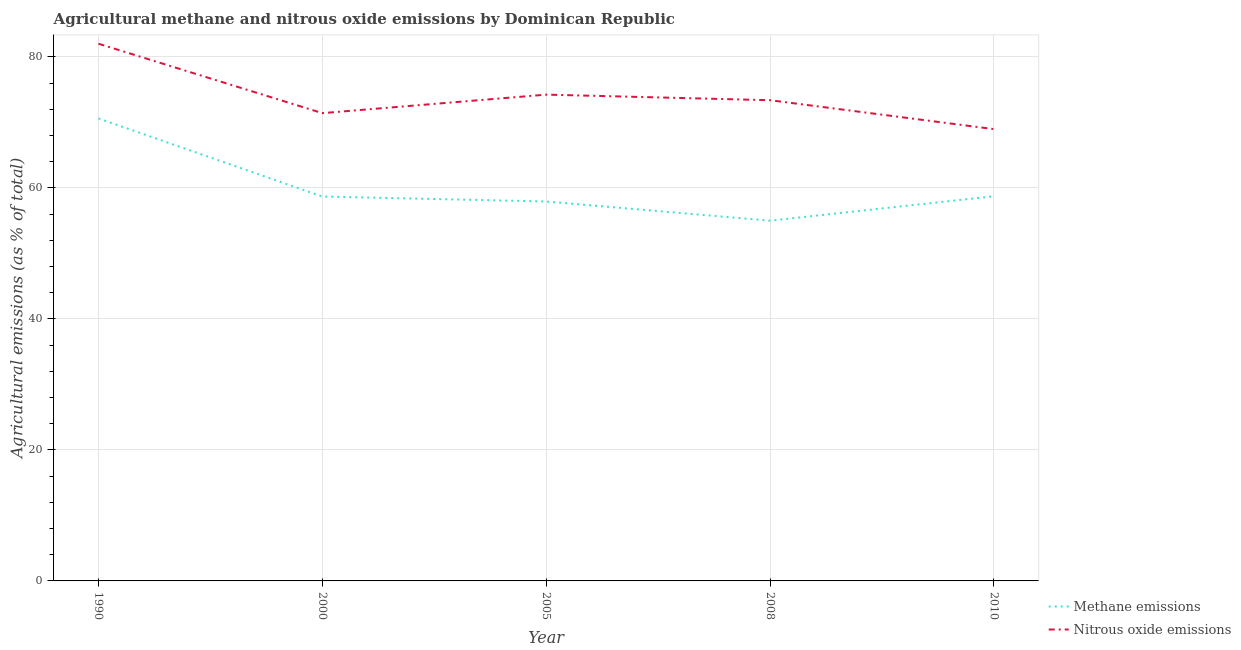Does the line corresponding to amount of methane emissions intersect with the line corresponding to amount of nitrous oxide emissions?
Your answer should be compact. No. What is the amount of methane emissions in 2005?
Give a very brief answer. 57.94. Across all years, what is the maximum amount of nitrous oxide emissions?
Ensure brevity in your answer.  82.03. Across all years, what is the minimum amount of methane emissions?
Provide a short and direct response. 55. What is the total amount of methane emissions in the graph?
Your answer should be compact. 300.99. What is the difference between the amount of nitrous oxide emissions in 2008 and that in 2010?
Offer a very short reply. 4.41. What is the difference between the amount of methane emissions in 2008 and the amount of nitrous oxide emissions in 2000?
Ensure brevity in your answer.  -16.42. What is the average amount of nitrous oxide emissions per year?
Give a very brief answer. 74.02. In the year 2010, what is the difference between the amount of methane emissions and amount of nitrous oxide emissions?
Keep it short and to the point. -10.25. What is the ratio of the amount of methane emissions in 2005 to that in 2008?
Make the answer very short. 1.05. Is the amount of nitrous oxide emissions in 2000 less than that in 2010?
Keep it short and to the point. No. What is the difference between the highest and the second highest amount of nitrous oxide emissions?
Offer a terse response. 7.77. What is the difference between the highest and the lowest amount of nitrous oxide emissions?
Offer a very short reply. 13.04. Is the sum of the amount of methane emissions in 1990 and 2010 greater than the maximum amount of nitrous oxide emissions across all years?
Your answer should be very brief. Yes. Does the amount of methane emissions monotonically increase over the years?
Make the answer very short. No. Is the amount of nitrous oxide emissions strictly greater than the amount of methane emissions over the years?
Provide a short and direct response. Yes. What is the difference between two consecutive major ticks on the Y-axis?
Keep it short and to the point. 20. Does the graph contain any zero values?
Your answer should be compact. No. How many legend labels are there?
Give a very brief answer. 2. How are the legend labels stacked?
Your answer should be very brief. Vertical. What is the title of the graph?
Ensure brevity in your answer.  Agricultural methane and nitrous oxide emissions by Dominican Republic. What is the label or title of the X-axis?
Ensure brevity in your answer.  Year. What is the label or title of the Y-axis?
Ensure brevity in your answer.  Agricultural emissions (as % of total). What is the Agricultural emissions (as % of total) in Methane emissions in 1990?
Your answer should be compact. 70.62. What is the Agricultural emissions (as % of total) in Nitrous oxide emissions in 1990?
Your answer should be compact. 82.03. What is the Agricultural emissions (as % of total) in Methane emissions in 2000?
Your answer should be very brief. 58.69. What is the Agricultural emissions (as % of total) in Nitrous oxide emissions in 2000?
Offer a terse response. 71.43. What is the Agricultural emissions (as % of total) in Methane emissions in 2005?
Your response must be concise. 57.94. What is the Agricultural emissions (as % of total) of Nitrous oxide emissions in 2005?
Provide a succinct answer. 74.25. What is the Agricultural emissions (as % of total) in Methane emissions in 2008?
Your response must be concise. 55. What is the Agricultural emissions (as % of total) in Nitrous oxide emissions in 2008?
Ensure brevity in your answer.  73.4. What is the Agricultural emissions (as % of total) in Methane emissions in 2010?
Offer a terse response. 58.74. What is the Agricultural emissions (as % of total) in Nitrous oxide emissions in 2010?
Keep it short and to the point. 68.99. Across all years, what is the maximum Agricultural emissions (as % of total) in Methane emissions?
Your answer should be very brief. 70.62. Across all years, what is the maximum Agricultural emissions (as % of total) of Nitrous oxide emissions?
Make the answer very short. 82.03. Across all years, what is the minimum Agricultural emissions (as % of total) of Methane emissions?
Your answer should be very brief. 55. Across all years, what is the minimum Agricultural emissions (as % of total) of Nitrous oxide emissions?
Offer a very short reply. 68.99. What is the total Agricultural emissions (as % of total) of Methane emissions in the graph?
Make the answer very short. 300.99. What is the total Agricultural emissions (as % of total) of Nitrous oxide emissions in the graph?
Keep it short and to the point. 370.09. What is the difference between the Agricultural emissions (as % of total) of Methane emissions in 1990 and that in 2000?
Make the answer very short. 11.92. What is the difference between the Agricultural emissions (as % of total) of Nitrous oxide emissions in 1990 and that in 2000?
Provide a short and direct response. 10.6. What is the difference between the Agricultural emissions (as % of total) of Methane emissions in 1990 and that in 2005?
Make the answer very short. 12.68. What is the difference between the Agricultural emissions (as % of total) of Nitrous oxide emissions in 1990 and that in 2005?
Give a very brief answer. 7.77. What is the difference between the Agricultural emissions (as % of total) of Methane emissions in 1990 and that in 2008?
Give a very brief answer. 15.61. What is the difference between the Agricultural emissions (as % of total) of Nitrous oxide emissions in 1990 and that in 2008?
Offer a very short reply. 8.63. What is the difference between the Agricultural emissions (as % of total) of Methane emissions in 1990 and that in 2010?
Your answer should be very brief. 11.88. What is the difference between the Agricultural emissions (as % of total) of Nitrous oxide emissions in 1990 and that in 2010?
Your answer should be very brief. 13.04. What is the difference between the Agricultural emissions (as % of total) of Methane emissions in 2000 and that in 2005?
Provide a short and direct response. 0.76. What is the difference between the Agricultural emissions (as % of total) of Nitrous oxide emissions in 2000 and that in 2005?
Provide a succinct answer. -2.83. What is the difference between the Agricultural emissions (as % of total) in Methane emissions in 2000 and that in 2008?
Ensure brevity in your answer.  3.69. What is the difference between the Agricultural emissions (as % of total) of Nitrous oxide emissions in 2000 and that in 2008?
Make the answer very short. -1.97. What is the difference between the Agricultural emissions (as % of total) of Methane emissions in 2000 and that in 2010?
Your answer should be very brief. -0.05. What is the difference between the Agricultural emissions (as % of total) in Nitrous oxide emissions in 2000 and that in 2010?
Ensure brevity in your answer.  2.44. What is the difference between the Agricultural emissions (as % of total) in Methane emissions in 2005 and that in 2008?
Offer a terse response. 2.93. What is the difference between the Agricultural emissions (as % of total) in Nitrous oxide emissions in 2005 and that in 2008?
Make the answer very short. 0.85. What is the difference between the Agricultural emissions (as % of total) in Methane emissions in 2005 and that in 2010?
Provide a succinct answer. -0.81. What is the difference between the Agricultural emissions (as % of total) of Nitrous oxide emissions in 2005 and that in 2010?
Your answer should be very brief. 5.27. What is the difference between the Agricultural emissions (as % of total) in Methane emissions in 2008 and that in 2010?
Provide a succinct answer. -3.74. What is the difference between the Agricultural emissions (as % of total) in Nitrous oxide emissions in 2008 and that in 2010?
Give a very brief answer. 4.41. What is the difference between the Agricultural emissions (as % of total) of Methane emissions in 1990 and the Agricultural emissions (as % of total) of Nitrous oxide emissions in 2000?
Your response must be concise. -0.81. What is the difference between the Agricultural emissions (as % of total) in Methane emissions in 1990 and the Agricultural emissions (as % of total) in Nitrous oxide emissions in 2005?
Offer a very short reply. -3.63. What is the difference between the Agricultural emissions (as % of total) in Methane emissions in 1990 and the Agricultural emissions (as % of total) in Nitrous oxide emissions in 2008?
Provide a short and direct response. -2.78. What is the difference between the Agricultural emissions (as % of total) in Methane emissions in 1990 and the Agricultural emissions (as % of total) in Nitrous oxide emissions in 2010?
Provide a short and direct response. 1.63. What is the difference between the Agricultural emissions (as % of total) of Methane emissions in 2000 and the Agricultural emissions (as % of total) of Nitrous oxide emissions in 2005?
Your answer should be compact. -15.56. What is the difference between the Agricultural emissions (as % of total) of Methane emissions in 2000 and the Agricultural emissions (as % of total) of Nitrous oxide emissions in 2008?
Offer a terse response. -14.71. What is the difference between the Agricultural emissions (as % of total) of Methane emissions in 2000 and the Agricultural emissions (as % of total) of Nitrous oxide emissions in 2010?
Ensure brevity in your answer.  -10.29. What is the difference between the Agricultural emissions (as % of total) of Methane emissions in 2005 and the Agricultural emissions (as % of total) of Nitrous oxide emissions in 2008?
Make the answer very short. -15.46. What is the difference between the Agricultural emissions (as % of total) in Methane emissions in 2005 and the Agricultural emissions (as % of total) in Nitrous oxide emissions in 2010?
Give a very brief answer. -11.05. What is the difference between the Agricultural emissions (as % of total) in Methane emissions in 2008 and the Agricultural emissions (as % of total) in Nitrous oxide emissions in 2010?
Your answer should be compact. -13.98. What is the average Agricultural emissions (as % of total) of Methane emissions per year?
Your answer should be compact. 60.2. What is the average Agricultural emissions (as % of total) of Nitrous oxide emissions per year?
Offer a terse response. 74.02. In the year 1990, what is the difference between the Agricultural emissions (as % of total) of Methane emissions and Agricultural emissions (as % of total) of Nitrous oxide emissions?
Offer a very short reply. -11.41. In the year 2000, what is the difference between the Agricultural emissions (as % of total) of Methane emissions and Agricultural emissions (as % of total) of Nitrous oxide emissions?
Keep it short and to the point. -12.73. In the year 2005, what is the difference between the Agricultural emissions (as % of total) of Methane emissions and Agricultural emissions (as % of total) of Nitrous oxide emissions?
Make the answer very short. -16.32. In the year 2008, what is the difference between the Agricultural emissions (as % of total) of Methane emissions and Agricultural emissions (as % of total) of Nitrous oxide emissions?
Your response must be concise. -18.4. In the year 2010, what is the difference between the Agricultural emissions (as % of total) in Methane emissions and Agricultural emissions (as % of total) in Nitrous oxide emissions?
Ensure brevity in your answer.  -10.25. What is the ratio of the Agricultural emissions (as % of total) of Methane emissions in 1990 to that in 2000?
Make the answer very short. 1.2. What is the ratio of the Agricultural emissions (as % of total) in Nitrous oxide emissions in 1990 to that in 2000?
Your response must be concise. 1.15. What is the ratio of the Agricultural emissions (as % of total) in Methane emissions in 1990 to that in 2005?
Offer a terse response. 1.22. What is the ratio of the Agricultural emissions (as % of total) of Nitrous oxide emissions in 1990 to that in 2005?
Offer a terse response. 1.1. What is the ratio of the Agricultural emissions (as % of total) in Methane emissions in 1990 to that in 2008?
Make the answer very short. 1.28. What is the ratio of the Agricultural emissions (as % of total) in Nitrous oxide emissions in 1990 to that in 2008?
Keep it short and to the point. 1.12. What is the ratio of the Agricultural emissions (as % of total) in Methane emissions in 1990 to that in 2010?
Keep it short and to the point. 1.2. What is the ratio of the Agricultural emissions (as % of total) of Nitrous oxide emissions in 1990 to that in 2010?
Give a very brief answer. 1.19. What is the ratio of the Agricultural emissions (as % of total) in Methane emissions in 2000 to that in 2005?
Your answer should be very brief. 1.01. What is the ratio of the Agricultural emissions (as % of total) of Nitrous oxide emissions in 2000 to that in 2005?
Your answer should be compact. 0.96. What is the ratio of the Agricultural emissions (as % of total) in Methane emissions in 2000 to that in 2008?
Provide a short and direct response. 1.07. What is the ratio of the Agricultural emissions (as % of total) of Nitrous oxide emissions in 2000 to that in 2008?
Give a very brief answer. 0.97. What is the ratio of the Agricultural emissions (as % of total) in Nitrous oxide emissions in 2000 to that in 2010?
Offer a terse response. 1.04. What is the ratio of the Agricultural emissions (as % of total) of Methane emissions in 2005 to that in 2008?
Offer a terse response. 1.05. What is the ratio of the Agricultural emissions (as % of total) of Nitrous oxide emissions in 2005 to that in 2008?
Offer a very short reply. 1.01. What is the ratio of the Agricultural emissions (as % of total) in Methane emissions in 2005 to that in 2010?
Your answer should be very brief. 0.99. What is the ratio of the Agricultural emissions (as % of total) in Nitrous oxide emissions in 2005 to that in 2010?
Ensure brevity in your answer.  1.08. What is the ratio of the Agricultural emissions (as % of total) of Methane emissions in 2008 to that in 2010?
Your answer should be compact. 0.94. What is the ratio of the Agricultural emissions (as % of total) of Nitrous oxide emissions in 2008 to that in 2010?
Your answer should be very brief. 1.06. What is the difference between the highest and the second highest Agricultural emissions (as % of total) of Methane emissions?
Your response must be concise. 11.88. What is the difference between the highest and the second highest Agricultural emissions (as % of total) of Nitrous oxide emissions?
Offer a terse response. 7.77. What is the difference between the highest and the lowest Agricultural emissions (as % of total) of Methane emissions?
Give a very brief answer. 15.61. What is the difference between the highest and the lowest Agricultural emissions (as % of total) of Nitrous oxide emissions?
Offer a very short reply. 13.04. 